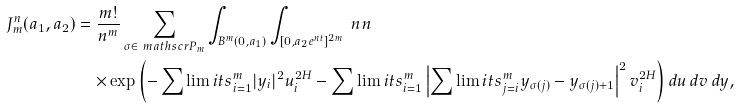<formula> <loc_0><loc_0><loc_500><loc_500>\ J ^ { n } _ { m } ( a _ { 1 } , a _ { 2 } ) & = \frac { m ! } { n ^ { m } } \sum _ { \sigma \in \ m a t h s c r { P } _ { m } } \int _ { B ^ { m } ( 0 , a _ { 1 } ) } \int _ { [ 0 , a _ { 2 } e ^ { n t } ] ^ { 2 m } } \ n n \\ & \quad \times \exp \left ( - \sum \lim i t s ^ { m } _ { i = 1 } | y _ { i } | ^ { 2 } u _ { i } ^ { 2 H } - \sum \lim i t s ^ { m } _ { i = 1 } \left | \sum \lim i t s ^ { m } _ { j = i } y _ { \sigma ( j ) } - y _ { \sigma ( j ) + 1 } \right | ^ { 2 } v _ { i } ^ { 2 H } \right ) d u \, d v \, d y ,</formula> 